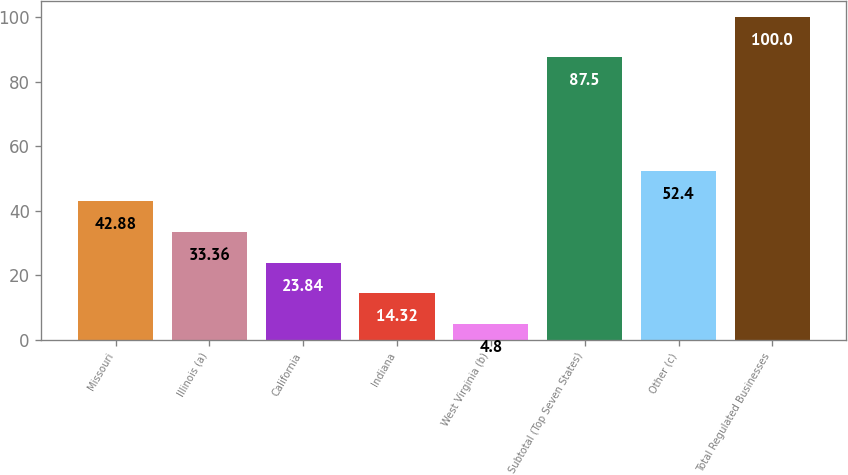Convert chart to OTSL. <chart><loc_0><loc_0><loc_500><loc_500><bar_chart><fcel>Missouri<fcel>Illinois (a)<fcel>California<fcel>Indiana<fcel>West Virginia (b)<fcel>Subtotal (Top Seven States)<fcel>Other (c)<fcel>Total Regulated Businesses<nl><fcel>42.88<fcel>33.36<fcel>23.84<fcel>14.32<fcel>4.8<fcel>87.5<fcel>52.4<fcel>100<nl></chart> 